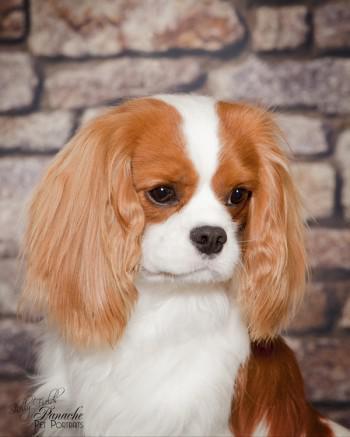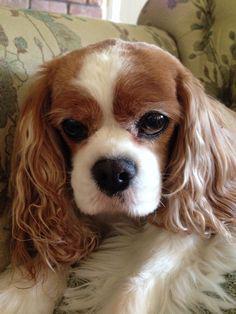The first image is the image on the left, the second image is the image on the right. Given the left and right images, does the statement "There is at least one dog on top of grass." hold true? Answer yes or no. No. The first image is the image on the left, the second image is the image on the right. For the images displayed, is the sentence "At least 1 brown and white dog is in the grass." factually correct? Answer yes or no. No. 